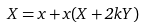<formula> <loc_0><loc_0><loc_500><loc_500>X = x + x ( X + 2 k Y )</formula> 